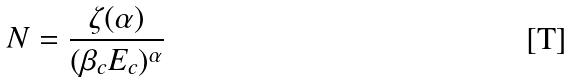<formula> <loc_0><loc_0><loc_500><loc_500>N = \frac { \zeta ( \alpha ) } { ( \beta _ { c } E _ { c } ) ^ { \alpha } }</formula> 